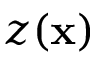Convert formula to latex. <formula><loc_0><loc_0><loc_500><loc_500>z ( x )</formula> 